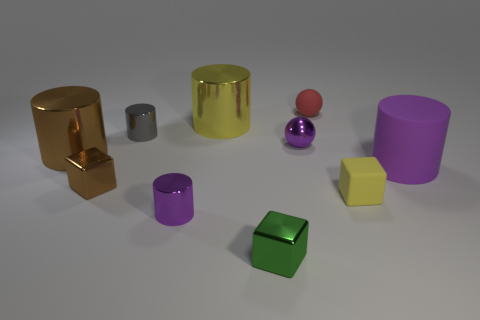Subtract all tiny metallic cylinders. How many cylinders are left? 3 Subtract 4 cylinders. How many cylinders are left? 1 Subtract 1 purple spheres. How many objects are left? 9 Subtract all balls. How many objects are left? 8 Subtract all red balls. Subtract all yellow cylinders. How many balls are left? 1 Subtract all green cubes. How many purple spheres are left? 1 Subtract all small brown rubber cylinders. Subtract all big yellow objects. How many objects are left? 9 Add 3 purple metallic balls. How many purple metallic balls are left? 4 Add 2 big purple metal spheres. How many big purple metal spheres exist? 2 Subtract all red balls. How many balls are left? 1 